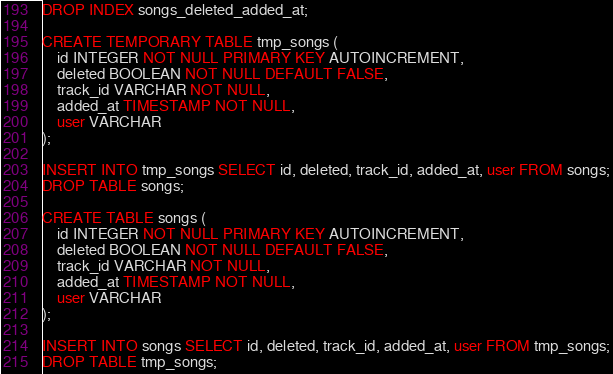Convert code to text. <code><loc_0><loc_0><loc_500><loc_500><_SQL_>DROP INDEX songs_deleted_added_at;

CREATE TEMPORARY TABLE tmp_songs (
    id INTEGER NOT NULL PRIMARY KEY AUTOINCREMENT,
    deleted BOOLEAN NOT NULL DEFAULT FALSE,
    track_id VARCHAR NOT NULL,
    added_at TIMESTAMP NOT NULL,
    user VARCHAR
);

INSERT INTO tmp_songs SELECT id, deleted, track_id, added_at, user FROM songs;
DROP TABLE songs;

CREATE TABLE songs (
    id INTEGER NOT NULL PRIMARY KEY AUTOINCREMENT,
    deleted BOOLEAN NOT NULL DEFAULT FALSE,
    track_id VARCHAR NOT NULL,
    added_at TIMESTAMP NOT NULL,
    user VARCHAR
);

INSERT INTO songs SELECT id, deleted, track_id, added_at, user FROM tmp_songs;
DROP TABLE tmp_songs;</code> 